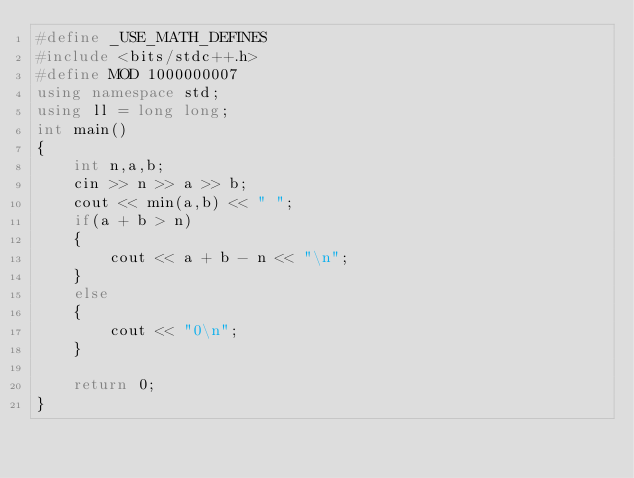<code> <loc_0><loc_0><loc_500><loc_500><_C++_>#define _USE_MATH_DEFINES
#include <bits/stdc++.h>
#define MOD 1000000007
using namespace std;
using ll = long long;
int main()
{
    int n,a,b;
    cin >> n >> a >> b;
    cout << min(a,b) << " ";
    if(a + b > n)
    {
        cout << a + b - n << "\n";
    }
    else
    {
        cout << "0\n";
    }
    
    return 0;
}</code> 